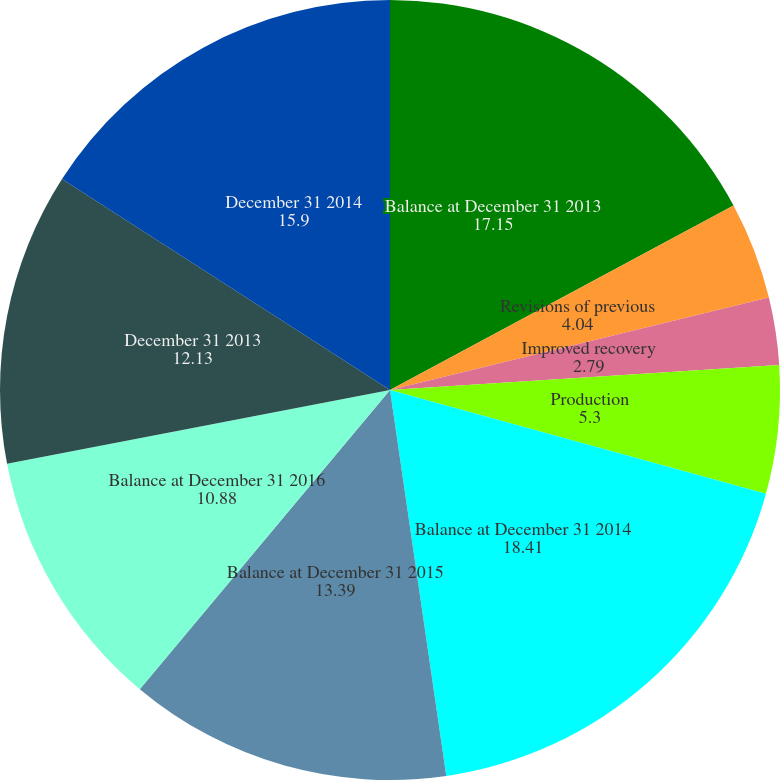<chart> <loc_0><loc_0><loc_500><loc_500><pie_chart><fcel>Balance at December 31 2013<fcel>Revisions of previous<fcel>Improved recovery<fcel>Production<fcel>Balance at December 31 2014<fcel>Balance at December 31 2015<fcel>Balance at December 31 2016<fcel>December 31 2013<fcel>December 31 2014<nl><fcel>17.15%<fcel>4.04%<fcel>2.79%<fcel>5.3%<fcel>18.41%<fcel>13.39%<fcel>10.88%<fcel>12.13%<fcel>15.9%<nl></chart> 